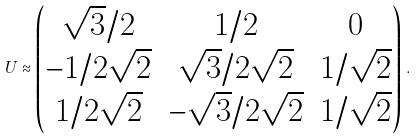<formula> <loc_0><loc_0><loc_500><loc_500>U \approx \begin{pmatrix} \sqrt { 3 } / 2 & 1 / 2 & 0 \\ - 1 / 2 \sqrt { 2 } & \sqrt { 3 } / 2 \sqrt { 2 } & 1 / \sqrt { 2 } \\ 1 / 2 \sqrt { 2 } & - \sqrt { 3 } / 2 \sqrt { 2 } & 1 / \sqrt { 2 } \end{pmatrix} \, .</formula> 